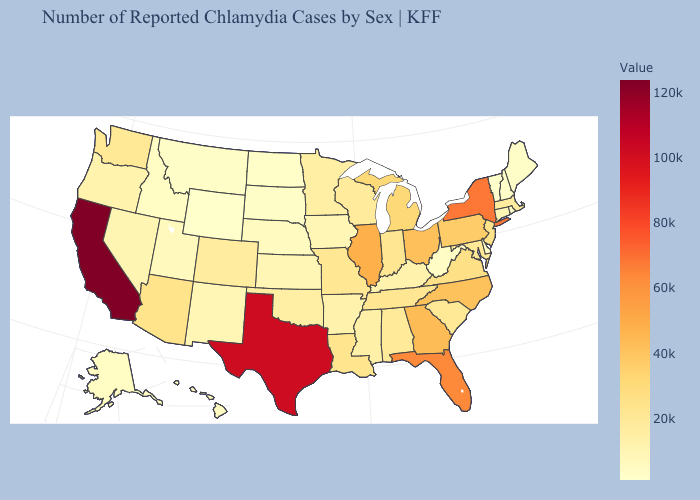Does New Mexico have the highest value in the West?
Concise answer only. No. Does Texas have the highest value in the South?
Answer briefly. Yes. Does New York have the highest value in the USA?
Concise answer only. No. 